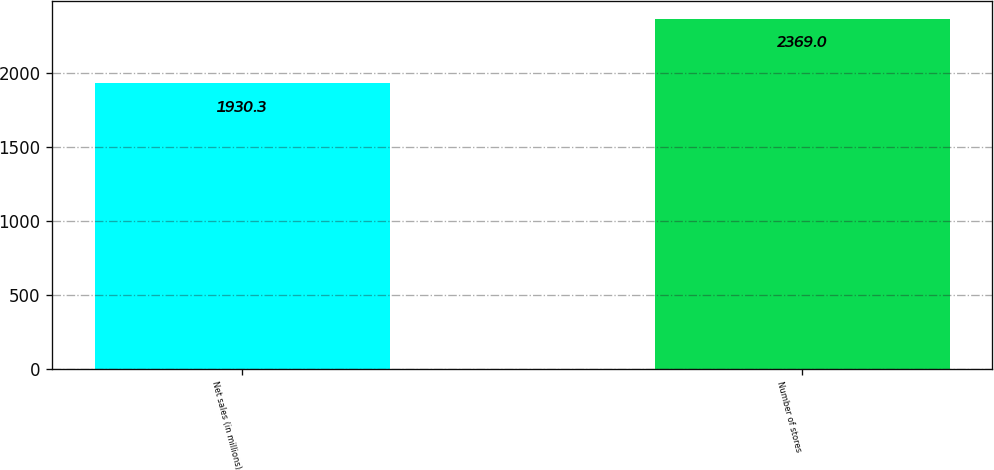Convert chart to OTSL. <chart><loc_0><loc_0><loc_500><loc_500><bar_chart><fcel>Net sales (in millions)<fcel>Number of stores<nl><fcel>1930.3<fcel>2369<nl></chart> 